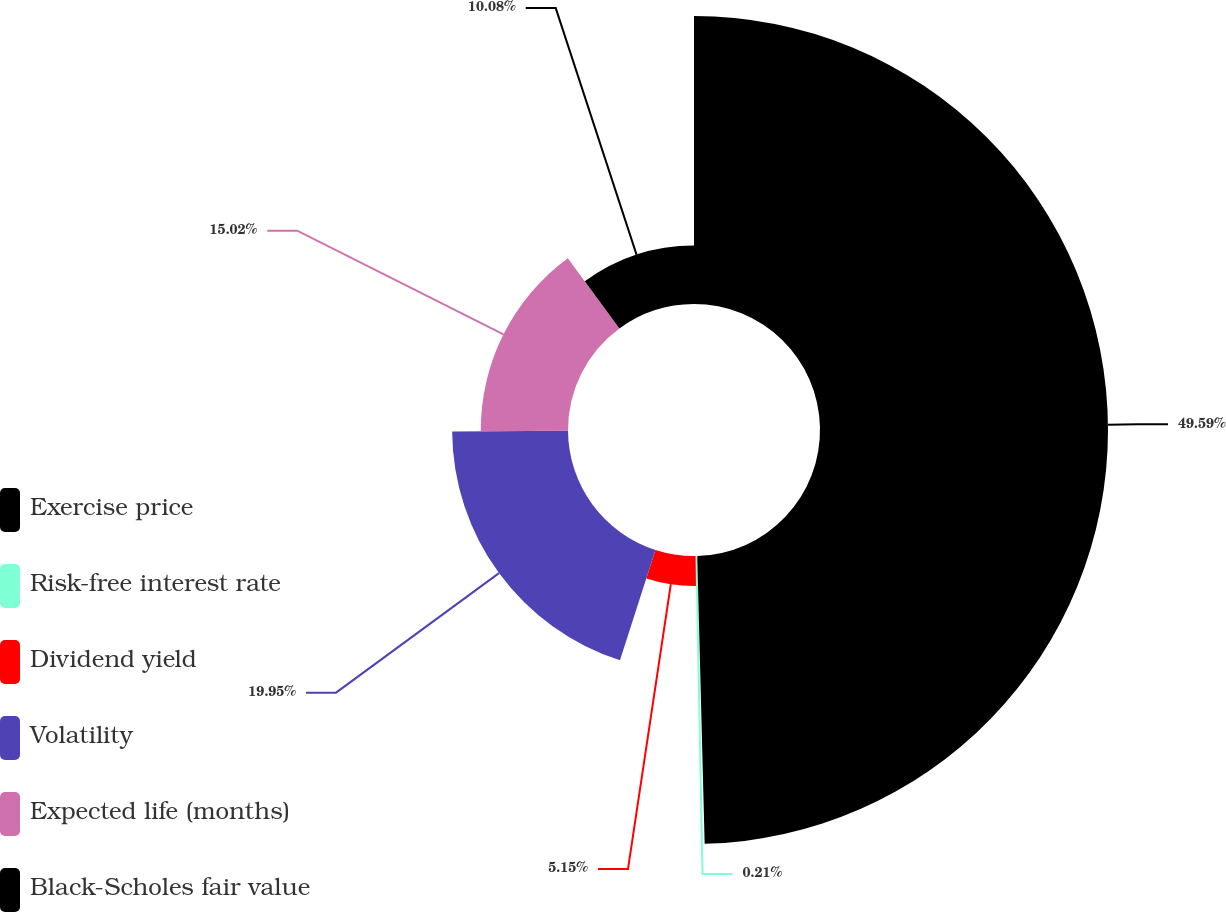Convert chart. <chart><loc_0><loc_0><loc_500><loc_500><pie_chart><fcel>Exercise price<fcel>Risk-free interest rate<fcel>Dividend yield<fcel>Volatility<fcel>Expected life (months)<fcel>Black-Scholes fair value<nl><fcel>49.59%<fcel>0.21%<fcel>5.15%<fcel>19.95%<fcel>15.02%<fcel>10.08%<nl></chart> 